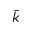Convert formula to latex. <formula><loc_0><loc_0><loc_500><loc_500>\ B a r { k }</formula> 